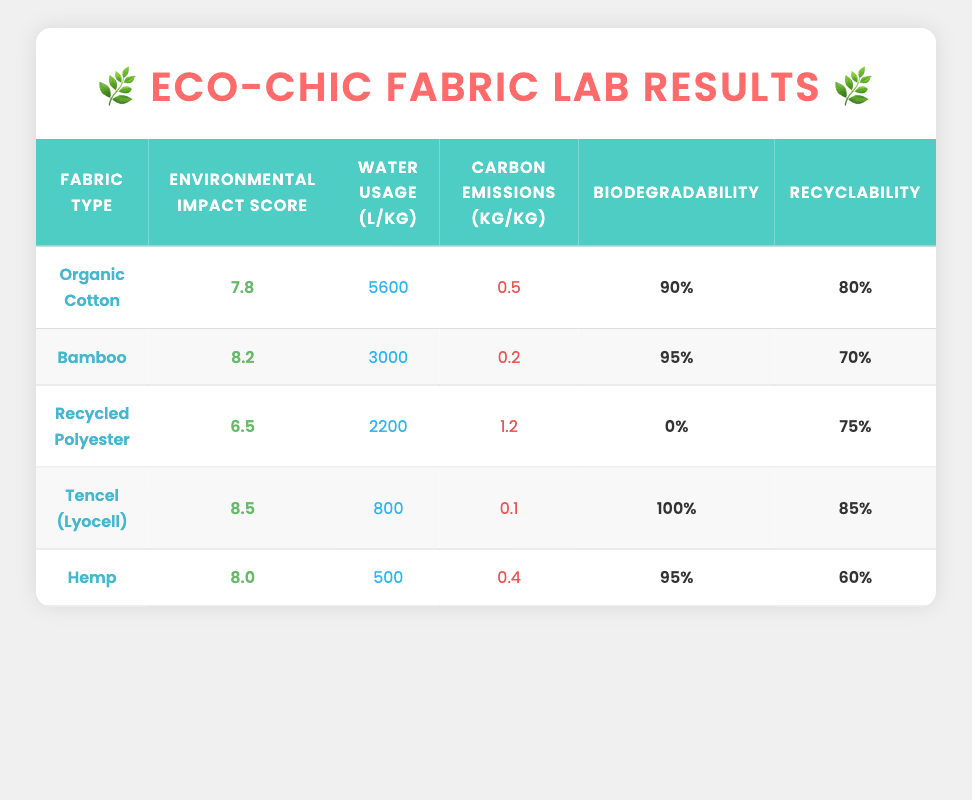What is the environmental impact score of Tencel (Lyocell)? The table shows the environmental impact score for each fabric type. For Tencel (Lyocell), the score is listed in the corresponding row, which is 8.5.
Answer: 8.5 Which fabric type has the lowest water usage per kilogram? By looking at the water usage column, we compare the values: Organic Cotton (5600), Bamboo (3000), Recycled Polyester (2200), Tencel (800), and Hemp (500). The lowest value is for Hemp, which is 500 liters per kilogram.
Answer: Hemp Is Bamboo more biodegradable than Organic Cotton? The biodegradability percentages for Bamboo (95%) and Organic Cotton (90%) can be directly compared from the table. Since 95% is greater than 90%, Bamboo is indeed more biodegradable.
Answer: Yes What is the total carbon emissions for Organic Cotton and Hemp combined? The carbon emissions for Organic Cotton is 0.5 kg/kg and for Hemp is 0.4 kg/kg. We sum these values: 0.5 + 0.4 = 0.9 kg/kg.
Answer: 0.9 kg/kg Which fabric type has the highest recyclability percentage? Looking at the recyclability column, the percentages are: Organic Cotton (80%), Bamboo (70%), Recycled Polyester (75%), Tencel (85%), and Hemp (60%). The highest value is for Tencel, which has a recyclability percentage of 85%.
Answer: Tencel (Lyocell) What is the average environmental impact score of all fabric types listed? The scores are: 7.8 (Organic Cotton), 8.2 (Bamboo), 6.5 (Recycled Polyester), 8.5 (Tencel), and 8.0 (Hemp). Adding these gives a total of (7.8 + 8.2 + 6.5 + 8.5 + 8.0) = 38. The average is then calculated by dividing the total by the number of fabric types (5), which is 38 / 5 = 7.6.
Answer: 7.6 Is Tencel (Lyocell) biodegradable? From the table, Tencel (Lyocell) has a biodegradability percentage of 100%. As this is a definitive yes, Tencel is indeed biodegradable.
Answer: Yes Which fabric type has a higher environmental impact score: Bamboo or Hemp? The environmental impact scores for Bamboo and Hemp are compared: Bamboo (8.2) and Hemp (8.0). Since 8.2 is greater than 8.0, Bamboo has the higher score.
Answer: Bamboo How much more water is used for Organic Cotton compared to Tencel (Lyocell)? The water usage for Organic Cotton is 5600 liters/kg and for Tencel (Lyocell) is 800 liters/kg. We calculate the difference: 5600 - 800 = 4800 liters/kg.
Answer: 4800 liters/kg 